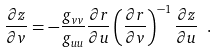<formula> <loc_0><loc_0><loc_500><loc_500>\frac { \partial z } { \partial v } = - \frac { g _ { v v } } { g _ { u u } } \frac { \partial r } { \partial u } \left ( \frac { \partial r } { \partial v } \right ) ^ { - 1 } \frac { \partial z } { \partial u } \ .</formula> 